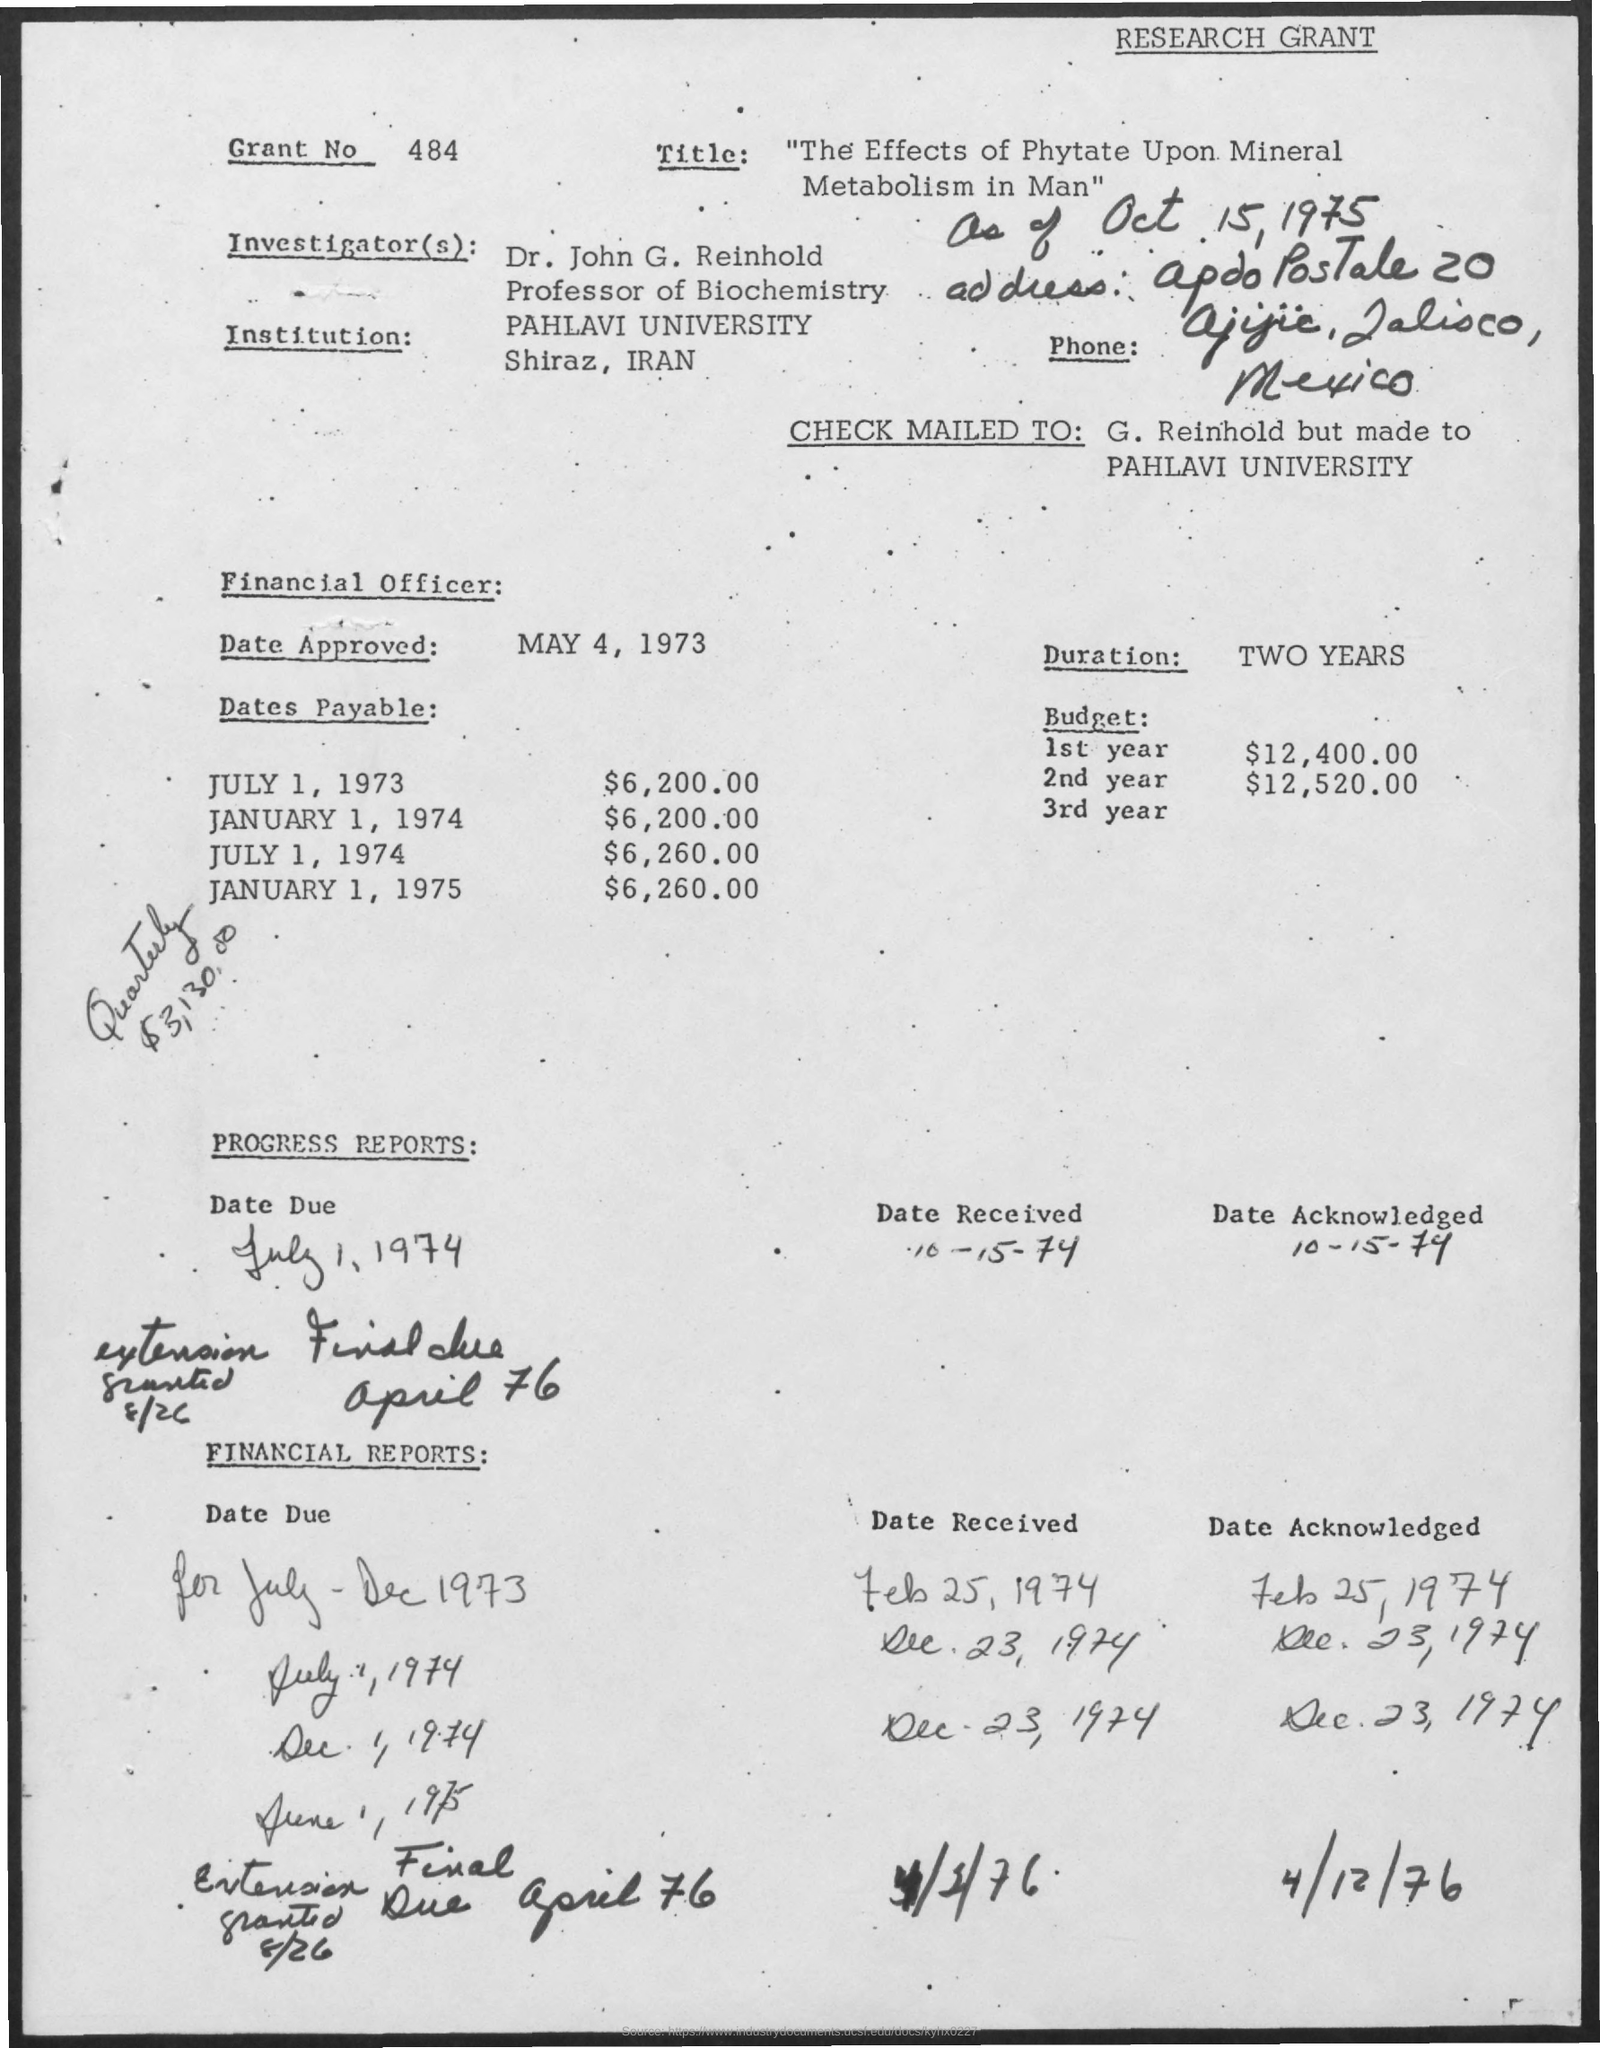Where is this PAHLAVI UNIVERSITY located?
Your answer should be compact. Shiraz, Iran. When  Financial Officer approved the CHECK?
Ensure brevity in your answer.  May 4, 1973. What's the Duration?
Make the answer very short. TWO YEARS. What is Budget for 2nd year?
Make the answer very short. $12,520.00. What is the amount Payable on JULY 1, 1974?
Ensure brevity in your answer.  $6,260.00. What is the last Date Acknowledge in FINANCIAL REPORT?
Keep it short and to the point. 4/12/76. What is the Date Received in PROGRESS REPORT?
Give a very brief answer. 10-15-74. How many dollars were Payable Quarterly?
Offer a terse response. 3,130.00. 